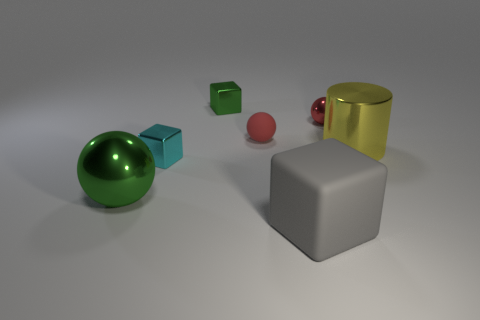The large object behind the small metal block that is in front of the green object behind the cyan metallic cube is what shape?
Make the answer very short. Cylinder. Is there a cyan block that has the same material as the big yellow cylinder?
Your answer should be compact. Yes. Do the tiny shiny object that is behind the tiny red shiny object and the metallic ball that is behind the green metallic ball have the same color?
Give a very brief answer. No. Are there fewer yellow metal objects that are on the left side of the red shiny thing than green balls?
Ensure brevity in your answer.  Yes. What number of things are cyan things or large things that are right of the large green metallic ball?
Offer a very short reply. 3. The other tiny cube that is made of the same material as the small cyan cube is what color?
Offer a very short reply. Green. How many objects are large blue metal spheres or metallic objects?
Offer a terse response. 5. There is a rubber block that is the same size as the yellow shiny cylinder; what is its color?
Provide a short and direct response. Gray. What number of objects are either shiny objects on the left side of the matte block or big gray rubber blocks?
Give a very brief answer. 4. What number of other objects are there of the same size as the yellow metal cylinder?
Your response must be concise. 2. 